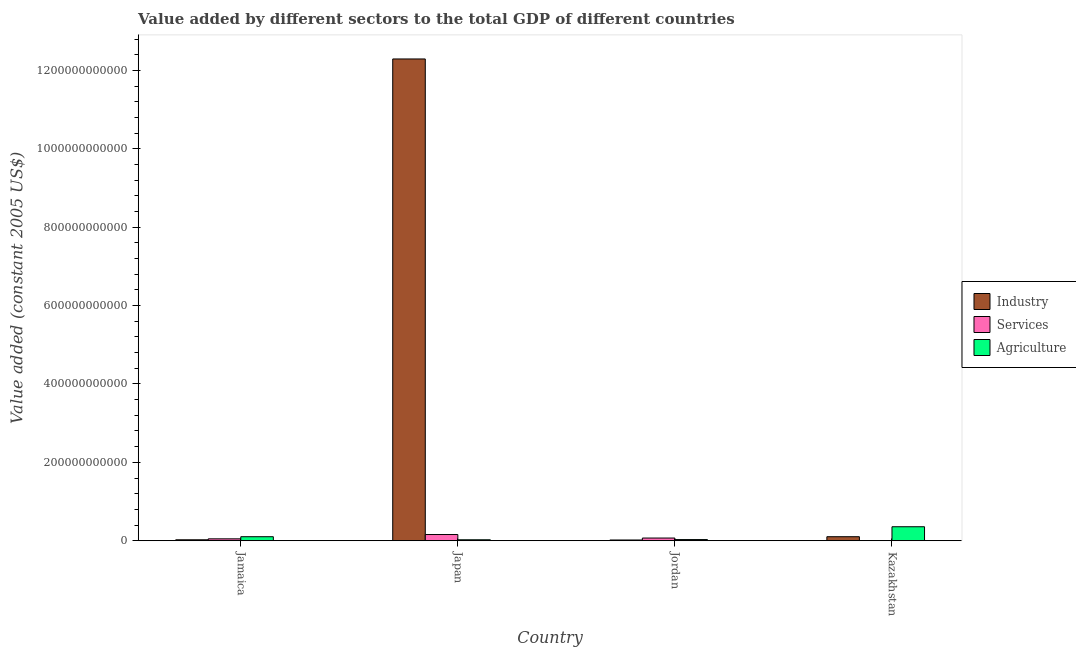How many different coloured bars are there?
Keep it short and to the point. 3. Are the number of bars on each tick of the X-axis equal?
Your answer should be very brief. Yes. What is the label of the 4th group of bars from the left?
Your answer should be compact. Kazakhstan. In how many cases, is the number of bars for a given country not equal to the number of legend labels?
Give a very brief answer. 0. What is the value added by services in Jamaica?
Your answer should be very brief. 4.82e+09. Across all countries, what is the maximum value added by industrial sector?
Keep it short and to the point. 1.23e+12. Across all countries, what is the minimum value added by agricultural sector?
Keep it short and to the point. 2.43e+09. In which country was the value added by services maximum?
Make the answer very short. Japan. In which country was the value added by services minimum?
Keep it short and to the point. Kazakhstan. What is the total value added by services in the graph?
Give a very brief answer. 2.75e+1. What is the difference between the value added by agricultural sector in Japan and that in Jordan?
Provide a short and direct response. -4.97e+08. What is the difference between the value added by industrial sector in Kazakhstan and the value added by agricultural sector in Jordan?
Offer a terse response. 7.32e+09. What is the average value added by services per country?
Your response must be concise. 6.87e+09. What is the difference between the value added by industrial sector and value added by agricultural sector in Kazakhstan?
Offer a terse response. -2.54e+1. What is the ratio of the value added by agricultural sector in Jordan to that in Kazakhstan?
Give a very brief answer. 0.08. Is the difference between the value added by services in Japan and Kazakhstan greater than the difference between the value added by agricultural sector in Japan and Kazakhstan?
Provide a short and direct response. Yes. What is the difference between the highest and the second highest value added by agricultural sector?
Provide a short and direct response. 2.54e+1. What is the difference between the highest and the lowest value added by agricultural sector?
Give a very brief answer. 3.33e+1. What does the 2nd bar from the left in Jamaica represents?
Offer a terse response. Services. What does the 3rd bar from the right in Japan represents?
Your response must be concise. Industry. Is it the case that in every country, the sum of the value added by industrial sector and value added by services is greater than the value added by agricultural sector?
Your response must be concise. No. How many bars are there?
Your answer should be very brief. 12. Are all the bars in the graph horizontal?
Ensure brevity in your answer.  No. What is the difference between two consecutive major ticks on the Y-axis?
Your answer should be very brief. 2.00e+11. Are the values on the major ticks of Y-axis written in scientific E-notation?
Your response must be concise. No. Does the graph contain grids?
Provide a succinct answer. No. How are the legend labels stacked?
Keep it short and to the point. Vertical. What is the title of the graph?
Keep it short and to the point. Value added by different sectors to the total GDP of different countries. What is the label or title of the X-axis?
Make the answer very short. Country. What is the label or title of the Y-axis?
Your response must be concise. Value added (constant 2005 US$). What is the Value added (constant 2005 US$) in Industry in Jamaica?
Give a very brief answer. 2.39e+09. What is the Value added (constant 2005 US$) of Services in Jamaica?
Your answer should be very brief. 4.82e+09. What is the Value added (constant 2005 US$) in Agriculture in Jamaica?
Your answer should be very brief. 1.02e+1. What is the Value added (constant 2005 US$) in Industry in Japan?
Your answer should be very brief. 1.23e+12. What is the Value added (constant 2005 US$) in Services in Japan?
Make the answer very short. 1.58e+1. What is the Value added (constant 2005 US$) of Agriculture in Japan?
Ensure brevity in your answer.  2.43e+09. What is the Value added (constant 2005 US$) of Industry in Jordan?
Your answer should be compact. 1.84e+09. What is the Value added (constant 2005 US$) in Services in Jordan?
Ensure brevity in your answer.  6.82e+09. What is the Value added (constant 2005 US$) of Agriculture in Jordan?
Offer a very short reply. 2.92e+09. What is the Value added (constant 2005 US$) of Industry in Kazakhstan?
Keep it short and to the point. 1.02e+1. What is the Value added (constant 2005 US$) of Services in Kazakhstan?
Your answer should be compact. 3.77e+07. What is the Value added (constant 2005 US$) in Agriculture in Kazakhstan?
Provide a short and direct response. 3.57e+1. Across all countries, what is the maximum Value added (constant 2005 US$) in Industry?
Offer a terse response. 1.23e+12. Across all countries, what is the maximum Value added (constant 2005 US$) in Services?
Give a very brief answer. 1.58e+1. Across all countries, what is the maximum Value added (constant 2005 US$) in Agriculture?
Offer a very short reply. 3.57e+1. Across all countries, what is the minimum Value added (constant 2005 US$) in Industry?
Give a very brief answer. 1.84e+09. Across all countries, what is the minimum Value added (constant 2005 US$) of Services?
Give a very brief answer. 3.77e+07. Across all countries, what is the minimum Value added (constant 2005 US$) in Agriculture?
Offer a terse response. 2.43e+09. What is the total Value added (constant 2005 US$) of Industry in the graph?
Make the answer very short. 1.24e+12. What is the total Value added (constant 2005 US$) of Services in the graph?
Your response must be concise. 2.75e+1. What is the total Value added (constant 2005 US$) in Agriculture in the graph?
Keep it short and to the point. 5.13e+1. What is the difference between the Value added (constant 2005 US$) in Industry in Jamaica and that in Japan?
Offer a terse response. -1.23e+12. What is the difference between the Value added (constant 2005 US$) of Services in Jamaica and that in Japan?
Your answer should be compact. -1.10e+1. What is the difference between the Value added (constant 2005 US$) in Agriculture in Jamaica and that in Japan?
Offer a terse response. 7.81e+09. What is the difference between the Value added (constant 2005 US$) in Industry in Jamaica and that in Jordan?
Offer a terse response. 5.51e+08. What is the difference between the Value added (constant 2005 US$) of Services in Jamaica and that in Jordan?
Your answer should be compact. -2.00e+09. What is the difference between the Value added (constant 2005 US$) in Agriculture in Jamaica and that in Jordan?
Make the answer very short. 7.31e+09. What is the difference between the Value added (constant 2005 US$) in Industry in Jamaica and that in Kazakhstan?
Your answer should be compact. -7.85e+09. What is the difference between the Value added (constant 2005 US$) of Services in Jamaica and that in Kazakhstan?
Offer a very short reply. 4.79e+09. What is the difference between the Value added (constant 2005 US$) in Agriculture in Jamaica and that in Kazakhstan?
Provide a succinct answer. -2.54e+1. What is the difference between the Value added (constant 2005 US$) of Industry in Japan and that in Jordan?
Your answer should be compact. 1.23e+12. What is the difference between the Value added (constant 2005 US$) in Services in Japan and that in Jordan?
Offer a terse response. 8.98e+09. What is the difference between the Value added (constant 2005 US$) of Agriculture in Japan and that in Jordan?
Your answer should be compact. -4.97e+08. What is the difference between the Value added (constant 2005 US$) of Industry in Japan and that in Kazakhstan?
Ensure brevity in your answer.  1.22e+12. What is the difference between the Value added (constant 2005 US$) in Services in Japan and that in Kazakhstan?
Your answer should be very brief. 1.58e+1. What is the difference between the Value added (constant 2005 US$) of Agriculture in Japan and that in Kazakhstan?
Give a very brief answer. -3.33e+1. What is the difference between the Value added (constant 2005 US$) in Industry in Jordan and that in Kazakhstan?
Make the answer very short. -8.40e+09. What is the difference between the Value added (constant 2005 US$) of Services in Jordan and that in Kazakhstan?
Give a very brief answer. 6.78e+09. What is the difference between the Value added (constant 2005 US$) in Agriculture in Jordan and that in Kazakhstan?
Your answer should be compact. -3.28e+1. What is the difference between the Value added (constant 2005 US$) of Industry in Jamaica and the Value added (constant 2005 US$) of Services in Japan?
Offer a very short reply. -1.34e+1. What is the difference between the Value added (constant 2005 US$) of Industry in Jamaica and the Value added (constant 2005 US$) of Agriculture in Japan?
Your answer should be very brief. -3.51e+07. What is the difference between the Value added (constant 2005 US$) in Services in Jamaica and the Value added (constant 2005 US$) in Agriculture in Japan?
Give a very brief answer. 2.40e+09. What is the difference between the Value added (constant 2005 US$) in Industry in Jamaica and the Value added (constant 2005 US$) in Services in Jordan?
Provide a succinct answer. -4.43e+09. What is the difference between the Value added (constant 2005 US$) in Industry in Jamaica and the Value added (constant 2005 US$) in Agriculture in Jordan?
Ensure brevity in your answer.  -5.32e+08. What is the difference between the Value added (constant 2005 US$) of Services in Jamaica and the Value added (constant 2005 US$) of Agriculture in Jordan?
Provide a short and direct response. 1.90e+09. What is the difference between the Value added (constant 2005 US$) in Industry in Jamaica and the Value added (constant 2005 US$) in Services in Kazakhstan?
Your response must be concise. 2.35e+09. What is the difference between the Value added (constant 2005 US$) in Industry in Jamaica and the Value added (constant 2005 US$) in Agriculture in Kazakhstan?
Offer a very short reply. -3.33e+1. What is the difference between the Value added (constant 2005 US$) in Services in Jamaica and the Value added (constant 2005 US$) in Agriculture in Kazakhstan?
Provide a succinct answer. -3.09e+1. What is the difference between the Value added (constant 2005 US$) in Industry in Japan and the Value added (constant 2005 US$) in Services in Jordan?
Offer a very short reply. 1.22e+12. What is the difference between the Value added (constant 2005 US$) of Industry in Japan and the Value added (constant 2005 US$) of Agriculture in Jordan?
Keep it short and to the point. 1.23e+12. What is the difference between the Value added (constant 2005 US$) of Services in Japan and the Value added (constant 2005 US$) of Agriculture in Jordan?
Your answer should be very brief. 1.29e+1. What is the difference between the Value added (constant 2005 US$) of Industry in Japan and the Value added (constant 2005 US$) of Services in Kazakhstan?
Your answer should be very brief. 1.23e+12. What is the difference between the Value added (constant 2005 US$) of Industry in Japan and the Value added (constant 2005 US$) of Agriculture in Kazakhstan?
Offer a very short reply. 1.19e+12. What is the difference between the Value added (constant 2005 US$) in Services in Japan and the Value added (constant 2005 US$) in Agriculture in Kazakhstan?
Offer a terse response. -1.99e+1. What is the difference between the Value added (constant 2005 US$) of Industry in Jordan and the Value added (constant 2005 US$) of Services in Kazakhstan?
Offer a terse response. 1.80e+09. What is the difference between the Value added (constant 2005 US$) of Industry in Jordan and the Value added (constant 2005 US$) of Agriculture in Kazakhstan?
Offer a very short reply. -3.38e+1. What is the difference between the Value added (constant 2005 US$) in Services in Jordan and the Value added (constant 2005 US$) in Agriculture in Kazakhstan?
Your answer should be very brief. -2.89e+1. What is the average Value added (constant 2005 US$) in Industry per country?
Provide a succinct answer. 3.11e+11. What is the average Value added (constant 2005 US$) in Services per country?
Provide a short and direct response. 6.87e+09. What is the average Value added (constant 2005 US$) in Agriculture per country?
Give a very brief answer. 1.28e+1. What is the difference between the Value added (constant 2005 US$) of Industry and Value added (constant 2005 US$) of Services in Jamaica?
Provide a short and direct response. -2.43e+09. What is the difference between the Value added (constant 2005 US$) in Industry and Value added (constant 2005 US$) in Agriculture in Jamaica?
Give a very brief answer. -7.85e+09. What is the difference between the Value added (constant 2005 US$) in Services and Value added (constant 2005 US$) in Agriculture in Jamaica?
Your response must be concise. -5.41e+09. What is the difference between the Value added (constant 2005 US$) in Industry and Value added (constant 2005 US$) in Services in Japan?
Ensure brevity in your answer.  1.21e+12. What is the difference between the Value added (constant 2005 US$) in Industry and Value added (constant 2005 US$) in Agriculture in Japan?
Your answer should be very brief. 1.23e+12. What is the difference between the Value added (constant 2005 US$) in Services and Value added (constant 2005 US$) in Agriculture in Japan?
Give a very brief answer. 1.34e+1. What is the difference between the Value added (constant 2005 US$) in Industry and Value added (constant 2005 US$) in Services in Jordan?
Your answer should be compact. -4.98e+09. What is the difference between the Value added (constant 2005 US$) of Industry and Value added (constant 2005 US$) of Agriculture in Jordan?
Offer a terse response. -1.08e+09. What is the difference between the Value added (constant 2005 US$) of Services and Value added (constant 2005 US$) of Agriculture in Jordan?
Provide a short and direct response. 3.90e+09. What is the difference between the Value added (constant 2005 US$) in Industry and Value added (constant 2005 US$) in Services in Kazakhstan?
Give a very brief answer. 1.02e+1. What is the difference between the Value added (constant 2005 US$) in Industry and Value added (constant 2005 US$) in Agriculture in Kazakhstan?
Offer a terse response. -2.54e+1. What is the difference between the Value added (constant 2005 US$) of Services and Value added (constant 2005 US$) of Agriculture in Kazakhstan?
Your answer should be very brief. -3.56e+1. What is the ratio of the Value added (constant 2005 US$) of Industry in Jamaica to that in Japan?
Keep it short and to the point. 0. What is the ratio of the Value added (constant 2005 US$) of Services in Jamaica to that in Japan?
Your answer should be very brief. 0.31. What is the ratio of the Value added (constant 2005 US$) of Agriculture in Jamaica to that in Japan?
Provide a succinct answer. 4.22. What is the ratio of the Value added (constant 2005 US$) in Industry in Jamaica to that in Jordan?
Keep it short and to the point. 1.3. What is the ratio of the Value added (constant 2005 US$) of Services in Jamaica to that in Jordan?
Keep it short and to the point. 0.71. What is the ratio of the Value added (constant 2005 US$) in Agriculture in Jamaica to that in Jordan?
Ensure brevity in your answer.  3.5. What is the ratio of the Value added (constant 2005 US$) in Industry in Jamaica to that in Kazakhstan?
Ensure brevity in your answer.  0.23. What is the ratio of the Value added (constant 2005 US$) in Services in Jamaica to that in Kazakhstan?
Ensure brevity in your answer.  127.83. What is the ratio of the Value added (constant 2005 US$) of Agriculture in Jamaica to that in Kazakhstan?
Provide a short and direct response. 0.29. What is the ratio of the Value added (constant 2005 US$) of Industry in Japan to that in Jordan?
Give a very brief answer. 667.97. What is the ratio of the Value added (constant 2005 US$) in Services in Japan to that in Jordan?
Offer a terse response. 2.32. What is the ratio of the Value added (constant 2005 US$) in Agriculture in Japan to that in Jordan?
Offer a terse response. 0.83. What is the ratio of the Value added (constant 2005 US$) in Industry in Japan to that in Kazakhstan?
Make the answer very short. 120. What is the ratio of the Value added (constant 2005 US$) in Services in Japan to that in Kazakhstan?
Keep it short and to the point. 418.69. What is the ratio of the Value added (constant 2005 US$) of Agriculture in Japan to that in Kazakhstan?
Make the answer very short. 0.07. What is the ratio of the Value added (constant 2005 US$) of Industry in Jordan to that in Kazakhstan?
Offer a terse response. 0.18. What is the ratio of the Value added (constant 2005 US$) in Services in Jordan to that in Kazakhstan?
Ensure brevity in your answer.  180.77. What is the ratio of the Value added (constant 2005 US$) in Agriculture in Jordan to that in Kazakhstan?
Provide a short and direct response. 0.08. What is the difference between the highest and the second highest Value added (constant 2005 US$) in Industry?
Offer a terse response. 1.22e+12. What is the difference between the highest and the second highest Value added (constant 2005 US$) of Services?
Provide a succinct answer. 8.98e+09. What is the difference between the highest and the second highest Value added (constant 2005 US$) of Agriculture?
Your response must be concise. 2.54e+1. What is the difference between the highest and the lowest Value added (constant 2005 US$) in Industry?
Provide a short and direct response. 1.23e+12. What is the difference between the highest and the lowest Value added (constant 2005 US$) of Services?
Offer a very short reply. 1.58e+1. What is the difference between the highest and the lowest Value added (constant 2005 US$) of Agriculture?
Your answer should be compact. 3.33e+1. 